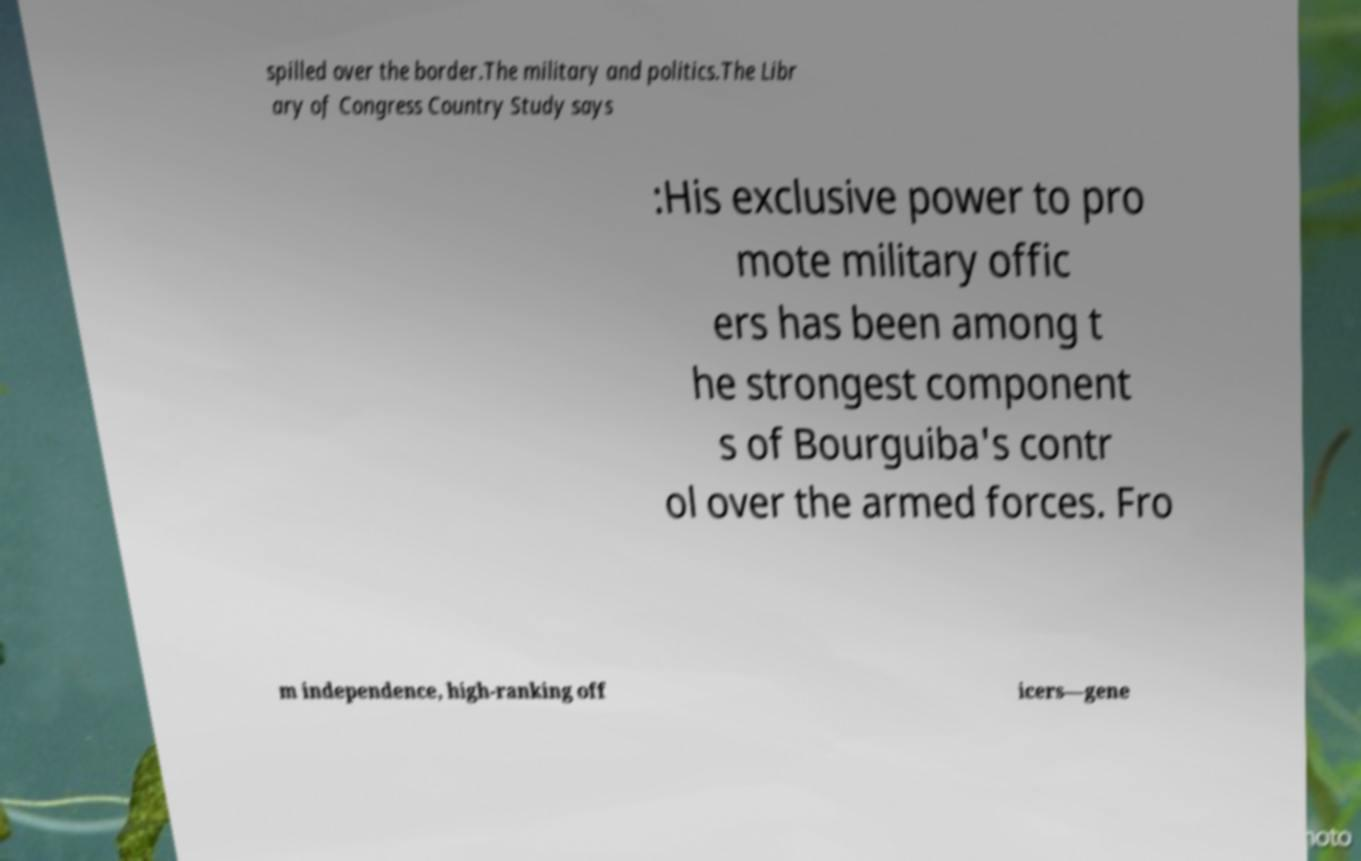What messages or text are displayed in this image? I need them in a readable, typed format. spilled over the border.The military and politics.The Libr ary of Congress Country Study says :His exclusive power to pro mote military offic ers has been among t he strongest component s of Bourguiba's contr ol over the armed forces. Fro m independence, high-ranking off icers—gene 